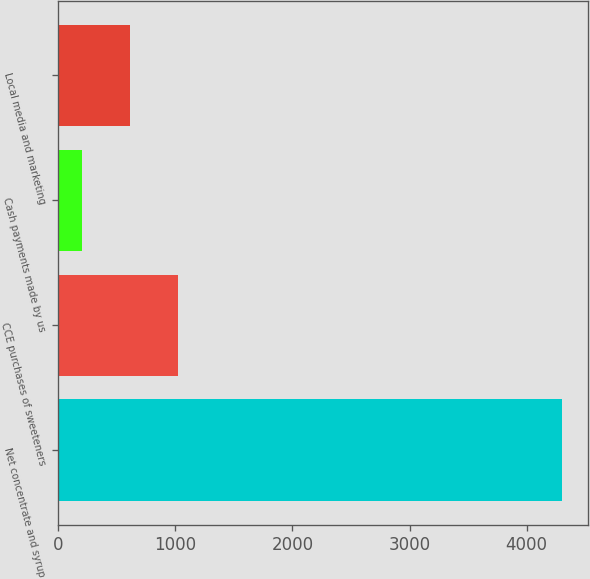Convert chart. <chart><loc_0><loc_0><loc_500><loc_500><bar_chart><fcel>Net concentrate and syrup<fcel>CCE purchases of sweeteners<fcel>Cash payments made by us<fcel>Local media and marketing<nl><fcel>4306<fcel>1024.4<fcel>204<fcel>614.2<nl></chart> 